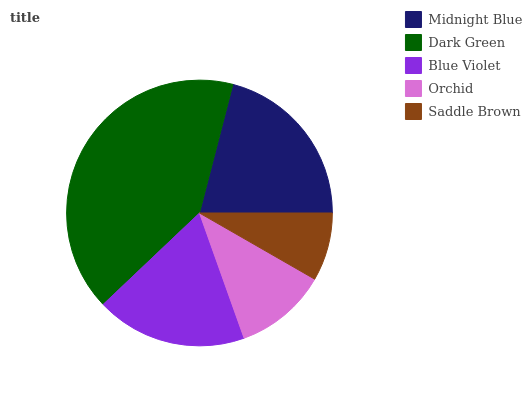Is Saddle Brown the minimum?
Answer yes or no. Yes. Is Dark Green the maximum?
Answer yes or no. Yes. Is Blue Violet the minimum?
Answer yes or no. No. Is Blue Violet the maximum?
Answer yes or no. No. Is Dark Green greater than Blue Violet?
Answer yes or no. Yes. Is Blue Violet less than Dark Green?
Answer yes or no. Yes. Is Blue Violet greater than Dark Green?
Answer yes or no. No. Is Dark Green less than Blue Violet?
Answer yes or no. No. Is Blue Violet the high median?
Answer yes or no. Yes. Is Blue Violet the low median?
Answer yes or no. Yes. Is Dark Green the high median?
Answer yes or no. No. Is Dark Green the low median?
Answer yes or no. No. 